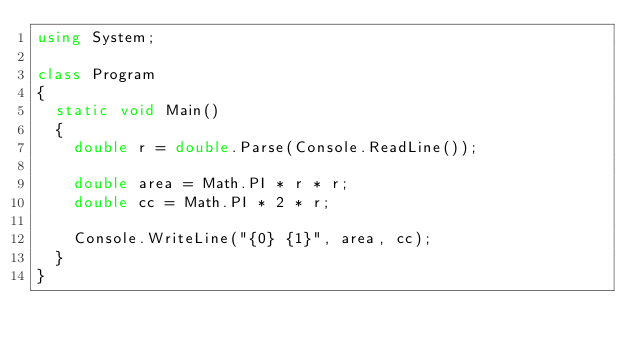Convert code to text. <code><loc_0><loc_0><loc_500><loc_500><_C#_>using System;

class Program
{
  static void Main()
  {
    double r = double.Parse(Console.ReadLine());

    double area = Math.PI * r * r;
    double cc = Math.PI * 2 * r;

    Console.WriteLine("{0} {1}", area, cc);
  }
}</code> 